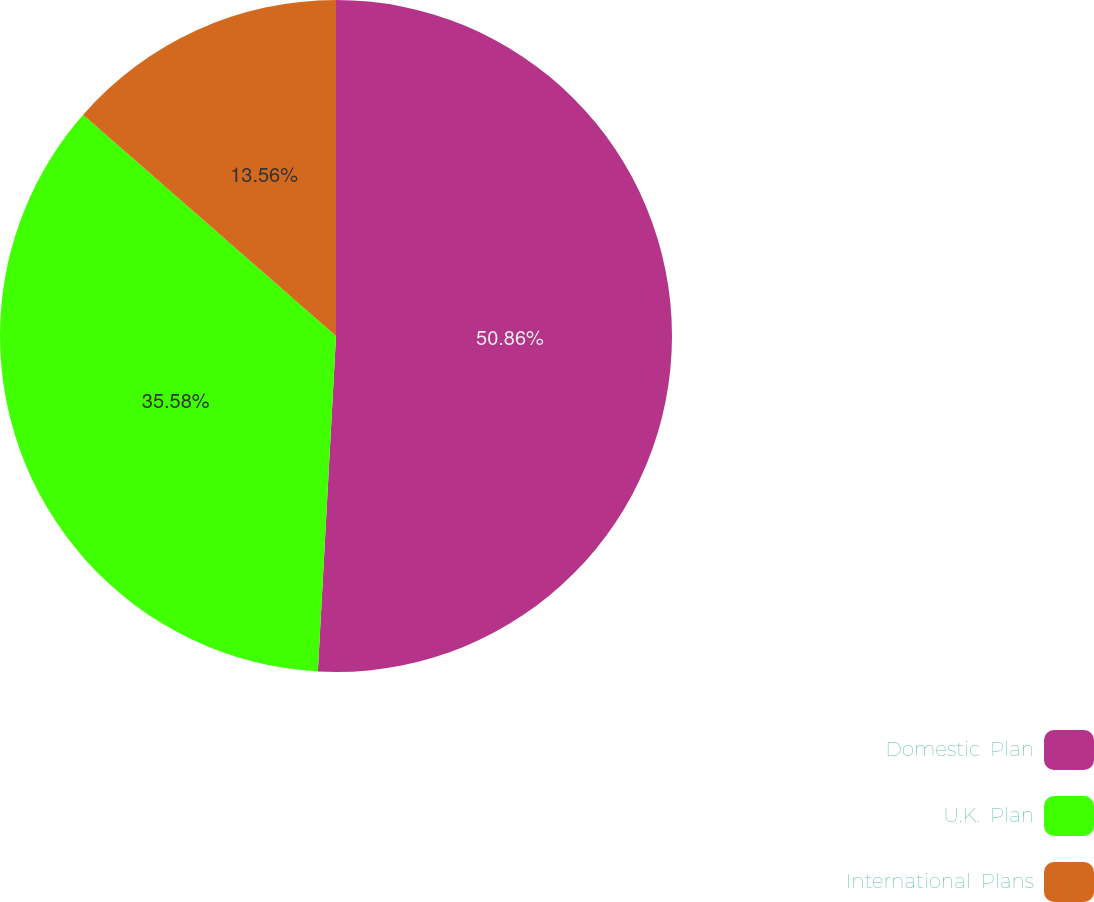Convert chart. <chart><loc_0><loc_0><loc_500><loc_500><pie_chart><fcel>Domestic  Plan<fcel>U.K.  Plan<fcel>International  Plans<nl><fcel>50.86%<fcel>35.58%<fcel>13.56%<nl></chart> 